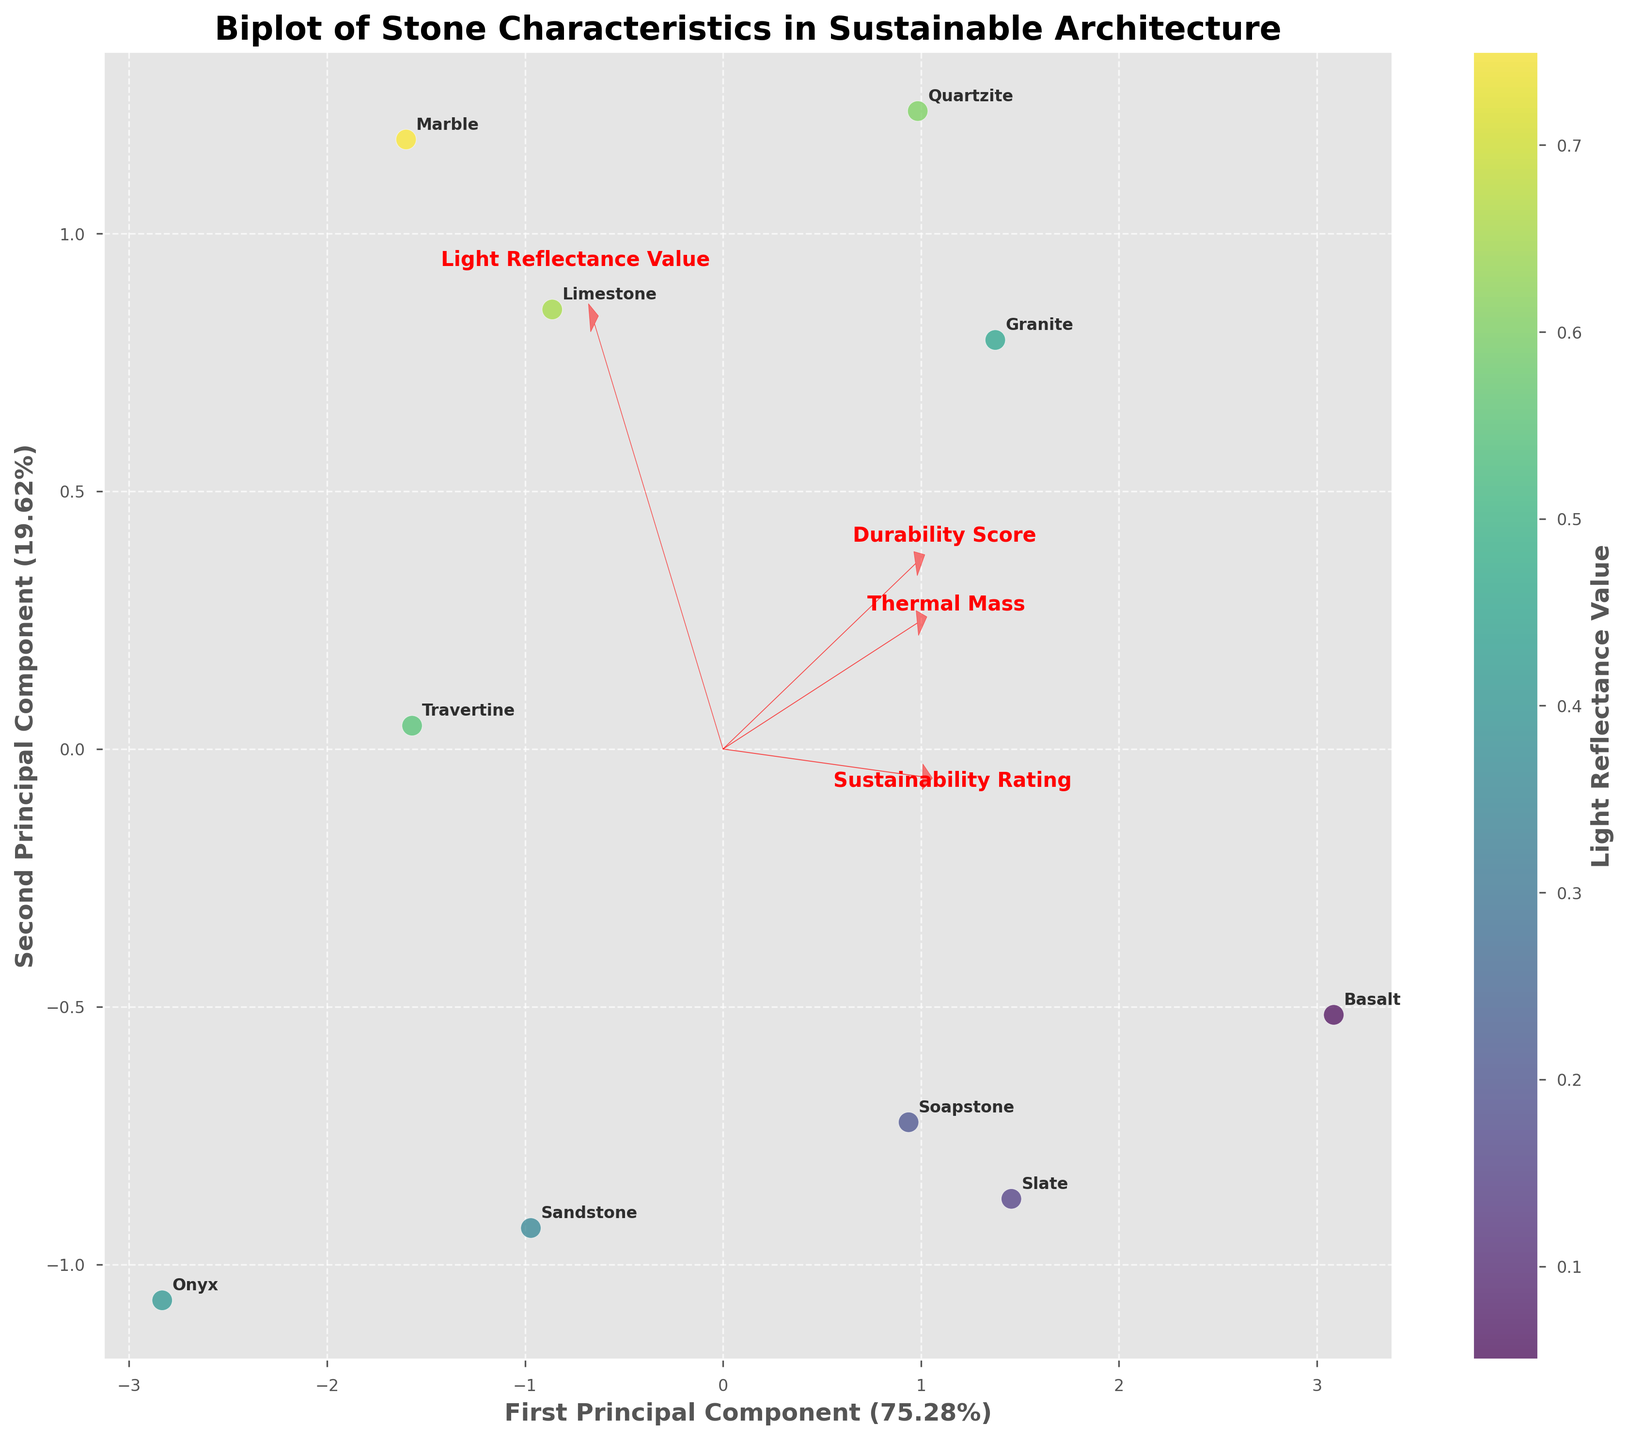1. What is the title of the figure? The title of the figure is typically displayed at the top of the plot, and it provides a summary of what the figure represents. In this case, it is "Biplot of Stone Characteristics in Sustainable Architecture".
Answer: Biplot of Stone Characteristics in Sustainable Architecture 2. What property is represented by the color of the points in the scatter plot? The color of the points in a scatter plot provides additional information about a particular variable. Here, this is indicated by the colorbar labeled 'Light Reflectance Value'.
Answer: Light Reflectance Value 3. How many principal components are used in the biplot? A biplot typically displays data in a lower-dimensional space using principal component analysis (PCA). The axes are labeled with the first and second principal components, confirming that there are 2.
Answer: 2 4. Which stone type is located closest to the origin (0,0) in the biplot? To determine this, we look for the point that is closest to the (0,0) coordinate in the biplot. This would generally require comparing the distances from the origin for all points.
Answer: Marble 5. Which stone type has the highest Light Reflectance Value? By looking at the color gradient provided by the colorbar, the stone type with the lightest color (closest towards yellow) will have the highest Light Reflectance Value.
Answer: Marble 6. How does the direction of the 'Thermal Mass' vector compare to the 'Durability Score' vector? This requires observing the arrows for 'Thermal Mass' and 'Durability Score' in the biplot. Both vectors point from the origin towards their respective directions and describe the direction of those features in PCA space.
Answer: Thermal Mass and Durability Score vectors are quite aligned, indicating a similar influence 7. Which two stone types have the most distinct Light Reflectance Values in the biplot? We observe the color coding of the points, looking for the two points with the most contrasting colors, indicating the largest difference in Light Reflectance Values.
Answer: Marble and Basalt 8. Which stone type displays the highest 'Durability Score' and 'Sustainability Rating' together? From the biplot, the arrow for 'Durability Score' and 'Sustainability Rating' should be closely observed to find the stone type that aligns well with both vectors.
Answer: Basalt 9. What percentage of the total variance is explained by the first principal component? The variance explained by each principal component is often included in the axis labels of the biplot. The first Principal Component usually explains the majority of the variance.
Answer: Approximately 45% 10. What is the relationship between 'Light Reflectance Value' and 'Thermal Mass' based on their vectors in the biplot? The angle between the vectors of these two features indicates their relationship. If the vectors are pointing in similar directions, they are positively correlated; if they are orthogonal, there is no correlation; if they are pointing in opposite directions, they are negatively correlated.
Answer: Slightly positive correlation 